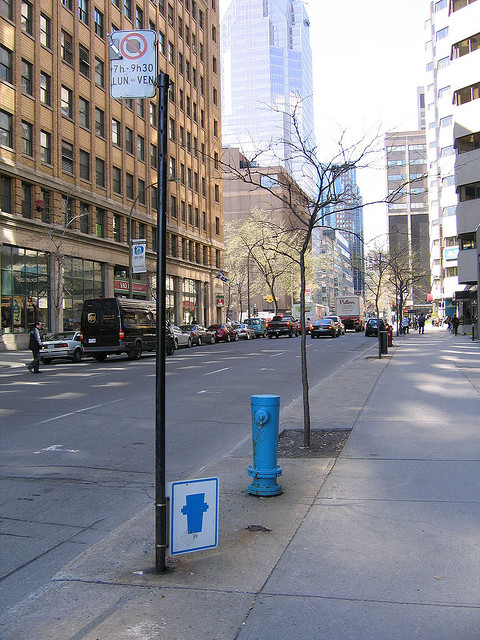Please identify all text content in this image. 7h 9h30 LUN VEN 